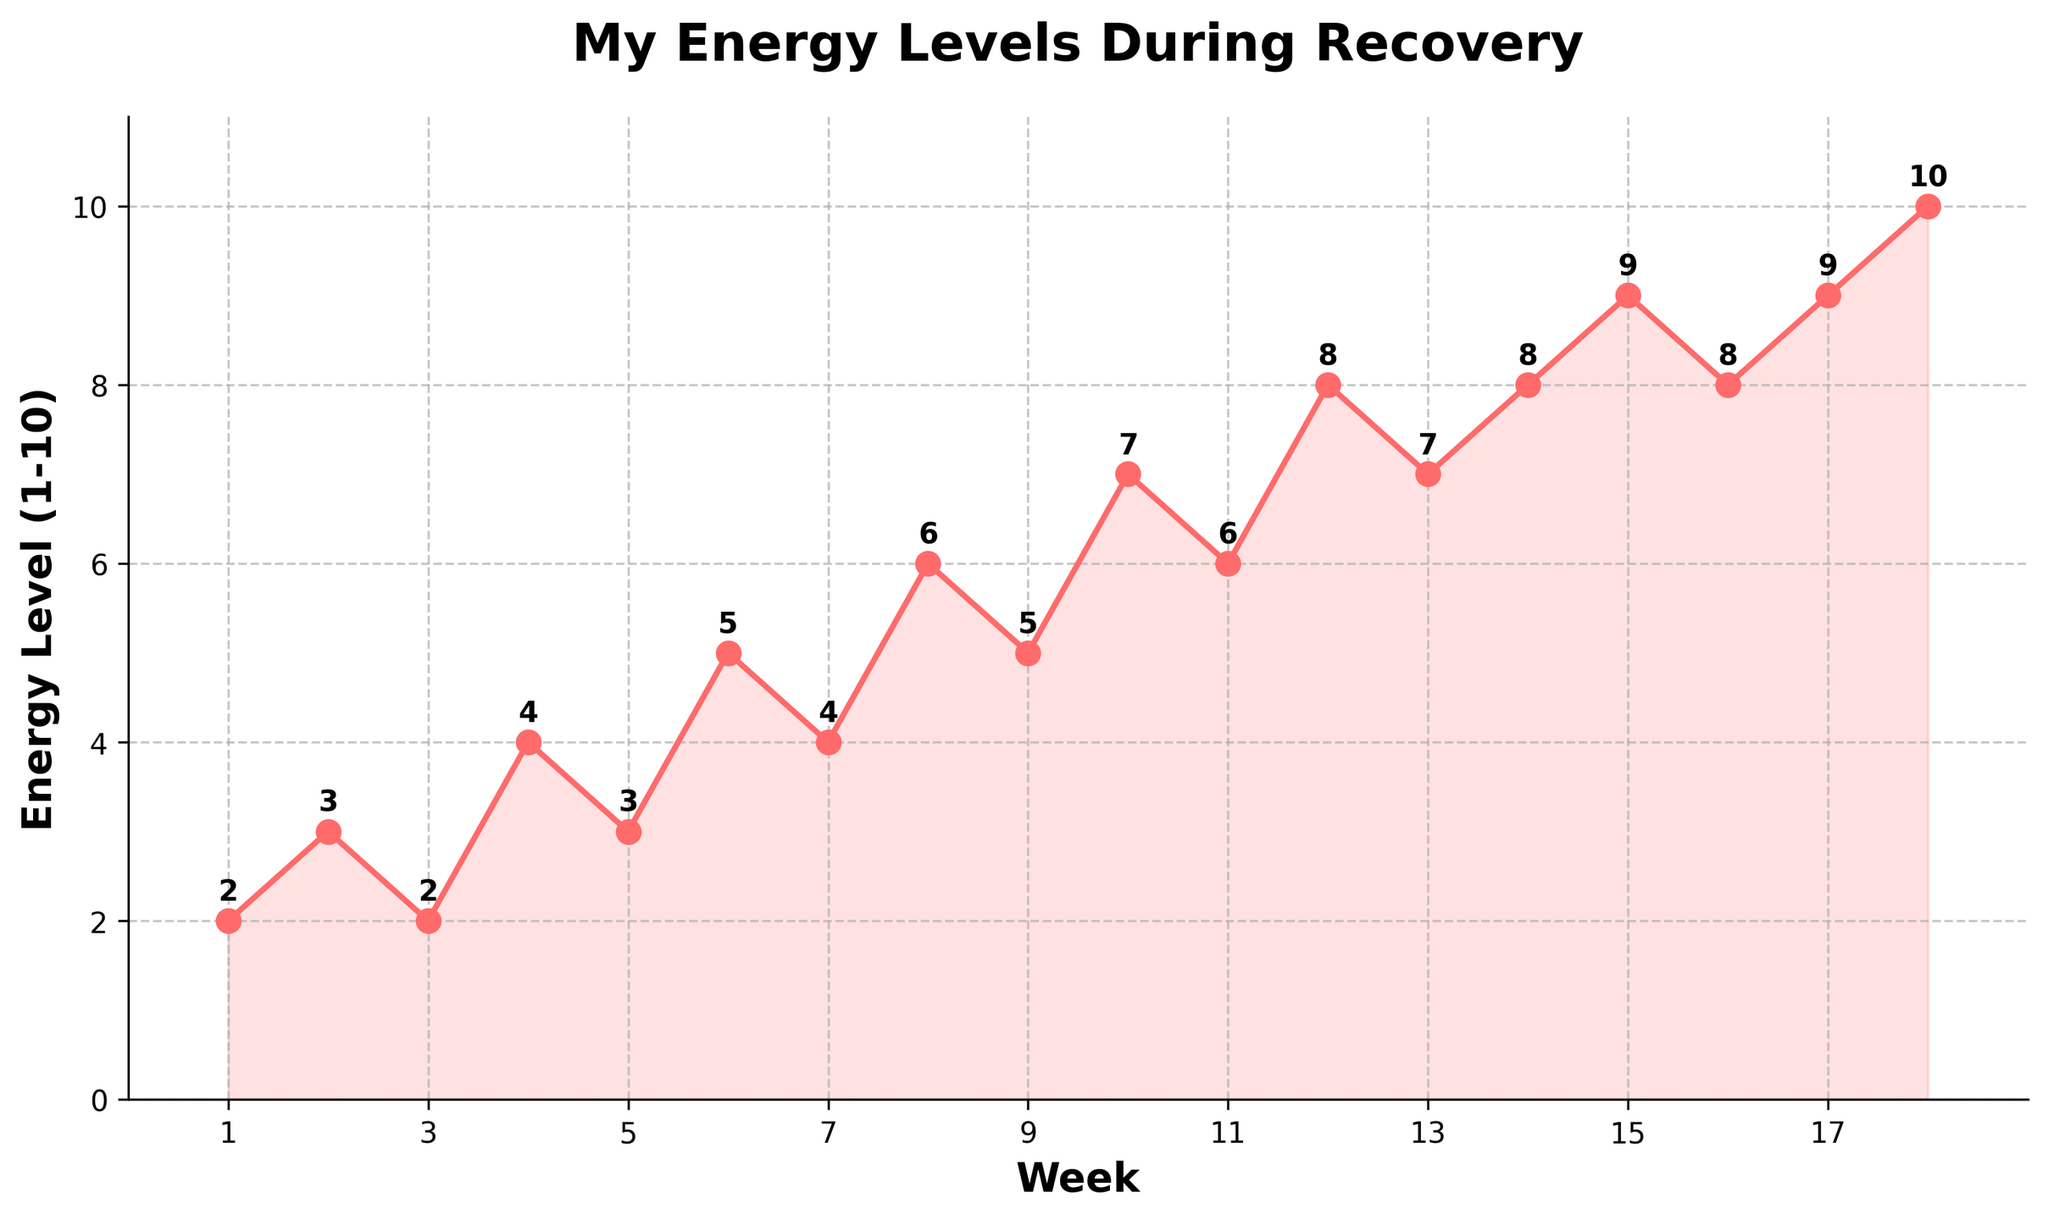What is the energy level at week 5? To answer, look directly at the value on the chart marked at week 5. The figure indicates an energy level of 3 at week 5.
Answer: 3 Did the energy level increase or decrease between week 3 and week 4? Look at the energy level values for week 3 and week 4. The value increases from 2 at week 3 to 4 at week 4.
Answer: Increase What is the highest energy level recorded in this period? Identify the maximum value on the y-axis for the energy levels. The highest recorded energy level is 10.
Answer: 10 How many weeks did it take for the energy level to reach 6 or above for the first time? Scan the x-axis to find the first instance where the energy level reaches 6. This occurs at week 8.
Answer: 8 Which week had the lowest energy level, and what was it? Identify the smallest value on the y-axis and the corresponding week. The lowest energy level is 2, which occurred at weeks 1 and 3.
Answer: Week 1 and 3, 2 What was the energy level change between week 10 and week 11? Note the energy levels at week 10 and week 11, then calculate the difference. The energy changed from 7 to 6, which is a decrease of 1.
Answer: Decrease of 1 What’s the average energy level from week 1 to week 9? Add up the energy levels from week 1 to week 9 and divide by the number of weeks: (2 + 3 + 2 + 4 + 3 + 5 + 4 + 6 + 5) / 9 = 34 / 9 ≈ 3.78
Answer: 3.78 During which weeks did the energy level not change compared to the previous week? Observe the plot for flat parts where the value remains unchanged: No change is seen between weeks 13-14, 15-16, and 17-18.
Answer: Weeks 13-14, 15-16, and 17-18 During which weeks did the largest increase in energy happen? Compare the differences in the energy levels between each pair of consecutive weeks. The largest increase is a rise of 2 from week 11 to week 12.
Answer: Weeks 11-12 Was the overall trend in energy levels increasing or decreasing over the 18 weeks? Analyze the start and end points, and the overall direction of the line. The energy levels show a general upward trend from 2 to 10.
Answer: Increasing 